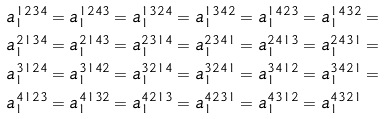<formula> <loc_0><loc_0><loc_500><loc_500>a _ { 1 } ^ { 1 2 3 4 } & = a _ { 1 } ^ { 1 2 4 3 } = a _ { 1 } ^ { 1 3 2 4 } = a _ { 1 } ^ { 1 3 4 2 } = a _ { 1 } ^ { 1 4 2 3 } = a _ { 1 } ^ { 1 4 3 2 } = \\ a _ { 1 } ^ { 2 1 3 4 } & = a _ { 1 } ^ { 2 1 4 3 } = a _ { 1 } ^ { 2 3 1 4 } = a _ { 1 } ^ { 2 3 4 1 } = a _ { 1 } ^ { 2 4 1 3 } = a _ { 1 } ^ { 2 4 3 1 } = \\ a _ { 1 } ^ { 3 1 2 4 } & = a _ { 1 } ^ { 3 1 4 2 } = a _ { 1 } ^ { 3 2 1 4 } = a _ { 1 } ^ { 3 2 4 1 } = a _ { 1 } ^ { 3 4 1 2 } = a _ { 1 } ^ { 3 4 2 1 } = \\ a _ { 1 } ^ { 4 1 2 3 } & = a _ { 1 } ^ { 4 1 3 2 } = a _ { 1 } ^ { 4 2 1 3 } = a _ { 1 } ^ { 4 2 3 1 } = a _ { 1 } ^ { 4 3 1 2 } = a _ { 1 } ^ { 4 3 2 1 }</formula> 